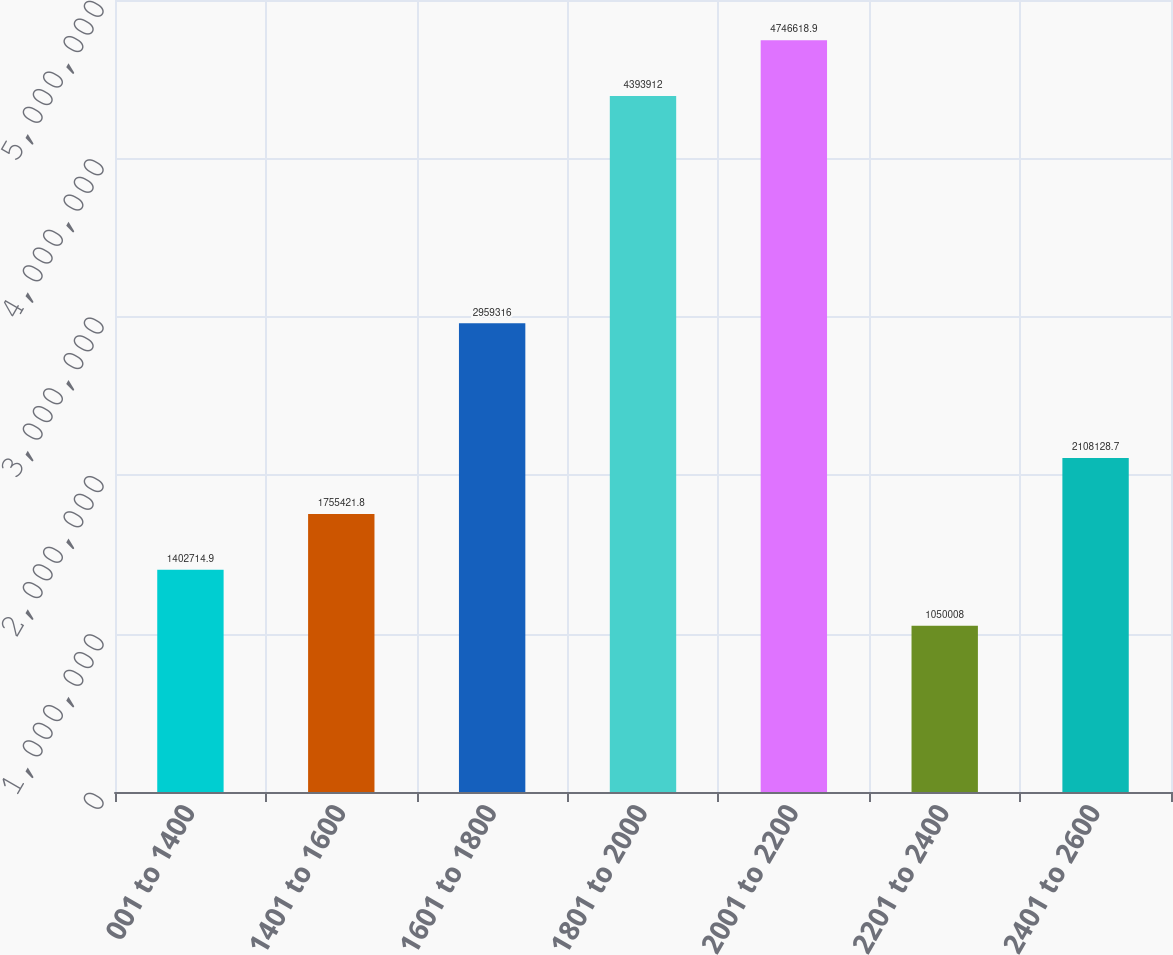Convert chart. <chart><loc_0><loc_0><loc_500><loc_500><bar_chart><fcel>001 to 1400<fcel>1401 to 1600<fcel>1601 to 1800<fcel>1801 to 2000<fcel>2001 to 2200<fcel>2201 to 2400<fcel>2401 to 2600<nl><fcel>1.40271e+06<fcel>1.75542e+06<fcel>2.95932e+06<fcel>4.39391e+06<fcel>4.74662e+06<fcel>1.05001e+06<fcel>2.10813e+06<nl></chart> 